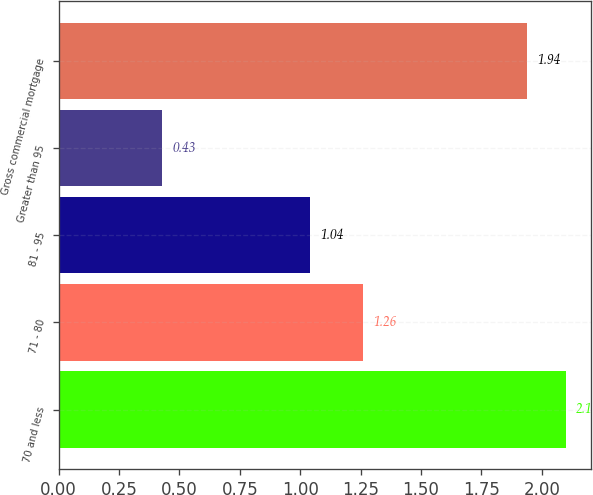<chart> <loc_0><loc_0><loc_500><loc_500><bar_chart><fcel>70 and less<fcel>71 - 80<fcel>81 - 95<fcel>Greater than 95<fcel>Gross commercial mortgage<nl><fcel>2.1<fcel>1.26<fcel>1.04<fcel>0.43<fcel>1.94<nl></chart> 